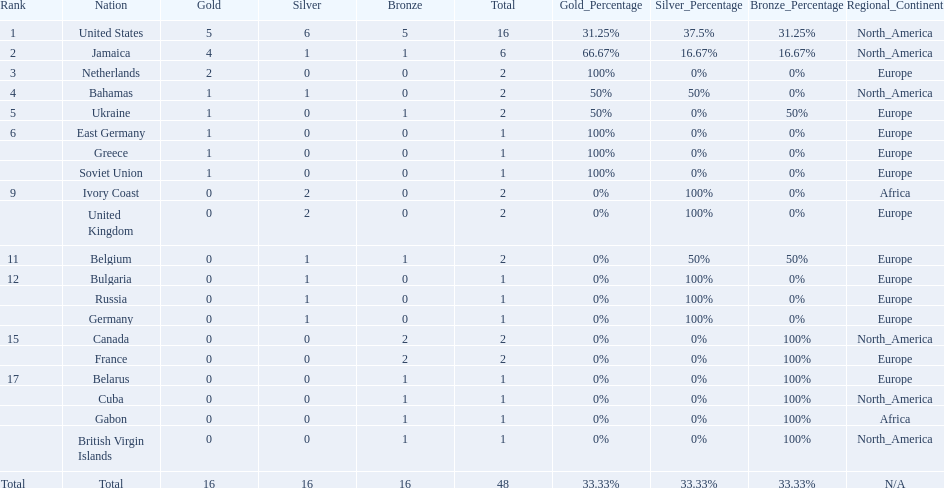What was the largest number of medals won by any country? 16. Which country won that many medals? United States. 